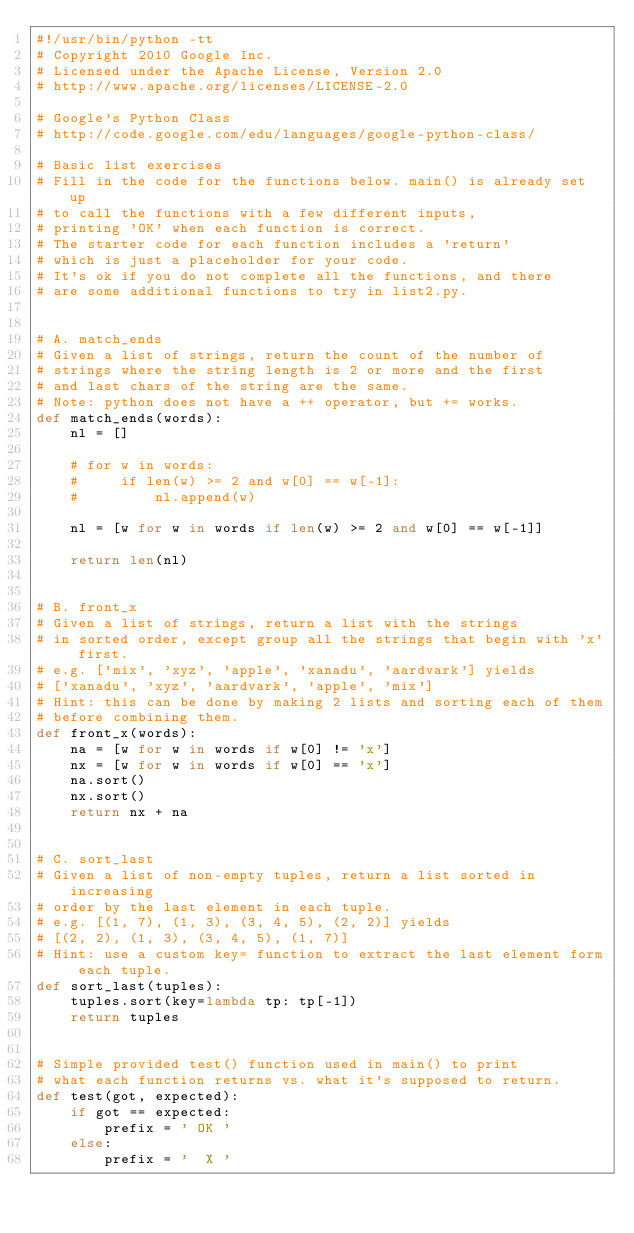Convert code to text. <code><loc_0><loc_0><loc_500><loc_500><_Python_>#!/usr/bin/python -tt
# Copyright 2010 Google Inc.
# Licensed under the Apache License, Version 2.0
# http://www.apache.org/licenses/LICENSE-2.0

# Google's Python Class
# http://code.google.com/edu/languages/google-python-class/

# Basic list exercises
# Fill in the code for the functions below. main() is already set up
# to call the functions with a few different inputs,
# printing 'OK' when each function is correct.
# The starter code for each function includes a 'return'
# which is just a placeholder for your code.
# It's ok if you do not complete all the functions, and there
# are some additional functions to try in list2.py.


# A. match_ends
# Given a list of strings, return the count of the number of
# strings where the string length is 2 or more and the first
# and last chars of the string are the same.
# Note: python does not have a ++ operator, but += works.
def match_ends(words):
    nl = []

    # for w in words:
    #     if len(w) >= 2 and w[0] == w[-1]:
    #         nl.append(w)

    nl = [w for w in words if len(w) >= 2 and w[0] == w[-1]]

    return len(nl)


# B. front_x
# Given a list of strings, return a list with the strings
# in sorted order, except group all the strings that begin with 'x' first.
# e.g. ['mix', 'xyz', 'apple', 'xanadu', 'aardvark'] yields
# ['xanadu', 'xyz', 'aardvark', 'apple', 'mix']
# Hint: this can be done by making 2 lists and sorting each of them
# before combining them.
def front_x(words):
    na = [w for w in words if w[0] != 'x']
    nx = [w for w in words if w[0] == 'x']
    na.sort()
    nx.sort()
    return nx + na


# C. sort_last
# Given a list of non-empty tuples, return a list sorted in increasing
# order by the last element in each tuple.
# e.g. [(1, 7), (1, 3), (3, 4, 5), (2, 2)] yields
# [(2, 2), (1, 3), (3, 4, 5), (1, 7)]
# Hint: use a custom key= function to extract the last element form each tuple.
def sort_last(tuples):
    tuples.sort(key=lambda tp: tp[-1])
    return tuples


# Simple provided test() function used in main() to print
# what each function returns vs. what it's supposed to return.
def test(got, expected):
    if got == expected:
        prefix = ' OK '
    else:
        prefix = '  X '</code> 